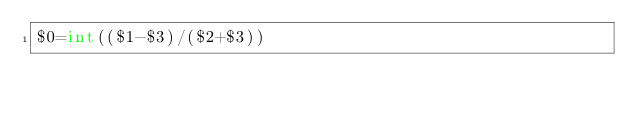Convert code to text. <code><loc_0><loc_0><loc_500><loc_500><_Awk_>$0=int(($1-$3)/($2+$3))</code> 